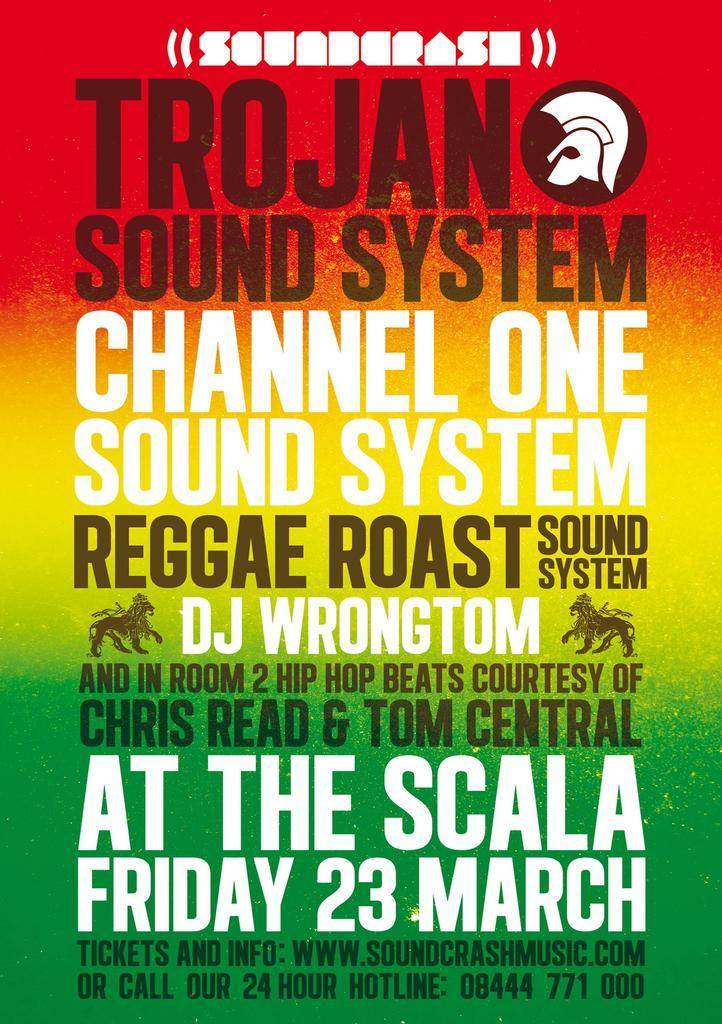<image>
Share a concise interpretation of the image provided. Poster for Trojan Soundsystem channel one sound system reggae roast sound system. 